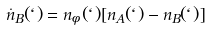<formula> <loc_0><loc_0><loc_500><loc_500>\dot { n } _ { B } ( \ell ) = n _ { \phi } ( \ell ) [ n _ { A } ( \ell ) - n _ { B } ( \ell ) ]</formula> 